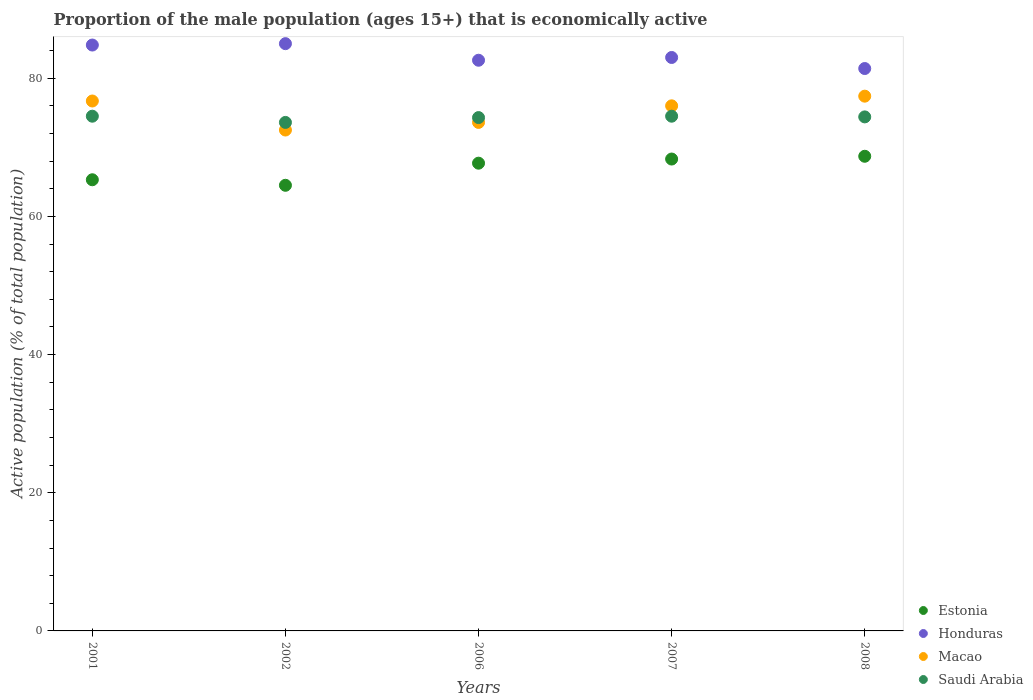Is the number of dotlines equal to the number of legend labels?
Your response must be concise. Yes. What is the proportion of the male population that is economically active in Honduras in 2002?
Give a very brief answer. 85. Across all years, what is the maximum proportion of the male population that is economically active in Macao?
Keep it short and to the point. 77.4. Across all years, what is the minimum proportion of the male population that is economically active in Macao?
Make the answer very short. 72.5. In which year was the proportion of the male population that is economically active in Honduras maximum?
Keep it short and to the point. 2002. In which year was the proportion of the male population that is economically active in Estonia minimum?
Provide a short and direct response. 2002. What is the total proportion of the male population that is economically active in Macao in the graph?
Your answer should be compact. 376.2. What is the difference between the proportion of the male population that is economically active in Honduras in 2002 and that in 2007?
Offer a very short reply. 2. What is the difference between the proportion of the male population that is economically active in Macao in 2002 and the proportion of the male population that is economically active in Estonia in 2008?
Offer a terse response. 3.8. What is the average proportion of the male population that is economically active in Honduras per year?
Offer a very short reply. 83.36. In the year 2002, what is the difference between the proportion of the male population that is economically active in Honduras and proportion of the male population that is economically active in Saudi Arabia?
Keep it short and to the point. 11.4. What is the ratio of the proportion of the male population that is economically active in Honduras in 2001 to that in 2006?
Your response must be concise. 1.03. Is the difference between the proportion of the male population that is economically active in Honduras in 2006 and 2008 greater than the difference between the proportion of the male population that is economically active in Saudi Arabia in 2006 and 2008?
Offer a very short reply. Yes. What is the difference between the highest and the second highest proportion of the male population that is economically active in Macao?
Give a very brief answer. 0.7. What is the difference between the highest and the lowest proportion of the male population that is economically active in Estonia?
Ensure brevity in your answer.  4.2. Is it the case that in every year, the sum of the proportion of the male population that is economically active in Macao and proportion of the male population that is economically active in Estonia  is greater than the sum of proportion of the male population that is economically active in Saudi Arabia and proportion of the male population that is economically active in Honduras?
Your answer should be compact. No. Is it the case that in every year, the sum of the proportion of the male population that is economically active in Macao and proportion of the male population that is economically active in Saudi Arabia  is greater than the proportion of the male population that is economically active in Honduras?
Keep it short and to the point. Yes. Does the proportion of the male population that is economically active in Honduras monotonically increase over the years?
Your answer should be compact. No. Is the proportion of the male population that is economically active in Honduras strictly greater than the proportion of the male population that is economically active in Macao over the years?
Give a very brief answer. Yes. Are the values on the major ticks of Y-axis written in scientific E-notation?
Make the answer very short. No. Does the graph contain any zero values?
Offer a terse response. No. Does the graph contain grids?
Offer a very short reply. No. How many legend labels are there?
Offer a terse response. 4. What is the title of the graph?
Offer a terse response. Proportion of the male population (ages 15+) that is economically active. Does "Liberia" appear as one of the legend labels in the graph?
Give a very brief answer. No. What is the label or title of the X-axis?
Provide a short and direct response. Years. What is the label or title of the Y-axis?
Provide a short and direct response. Active population (% of total population). What is the Active population (% of total population) of Estonia in 2001?
Give a very brief answer. 65.3. What is the Active population (% of total population) in Honduras in 2001?
Make the answer very short. 84.8. What is the Active population (% of total population) in Macao in 2001?
Provide a succinct answer. 76.7. What is the Active population (% of total population) in Saudi Arabia in 2001?
Give a very brief answer. 74.5. What is the Active population (% of total population) of Estonia in 2002?
Give a very brief answer. 64.5. What is the Active population (% of total population) in Honduras in 2002?
Offer a terse response. 85. What is the Active population (% of total population) in Macao in 2002?
Ensure brevity in your answer.  72.5. What is the Active population (% of total population) in Saudi Arabia in 2002?
Give a very brief answer. 73.6. What is the Active population (% of total population) in Estonia in 2006?
Ensure brevity in your answer.  67.7. What is the Active population (% of total population) of Honduras in 2006?
Keep it short and to the point. 82.6. What is the Active population (% of total population) in Macao in 2006?
Offer a very short reply. 73.6. What is the Active population (% of total population) in Saudi Arabia in 2006?
Offer a very short reply. 74.3. What is the Active population (% of total population) in Estonia in 2007?
Provide a short and direct response. 68.3. What is the Active population (% of total population) of Honduras in 2007?
Offer a terse response. 83. What is the Active population (% of total population) in Macao in 2007?
Offer a very short reply. 76. What is the Active population (% of total population) in Saudi Arabia in 2007?
Provide a short and direct response. 74.5. What is the Active population (% of total population) in Estonia in 2008?
Your answer should be compact. 68.7. What is the Active population (% of total population) of Honduras in 2008?
Provide a succinct answer. 81.4. What is the Active population (% of total population) in Macao in 2008?
Provide a short and direct response. 77.4. What is the Active population (% of total population) of Saudi Arabia in 2008?
Offer a very short reply. 74.4. Across all years, what is the maximum Active population (% of total population) of Estonia?
Your answer should be compact. 68.7. Across all years, what is the maximum Active population (% of total population) in Honduras?
Offer a terse response. 85. Across all years, what is the maximum Active population (% of total population) in Macao?
Provide a short and direct response. 77.4. Across all years, what is the maximum Active population (% of total population) in Saudi Arabia?
Provide a succinct answer. 74.5. Across all years, what is the minimum Active population (% of total population) of Estonia?
Make the answer very short. 64.5. Across all years, what is the minimum Active population (% of total population) in Honduras?
Offer a very short reply. 81.4. Across all years, what is the minimum Active population (% of total population) in Macao?
Your answer should be very brief. 72.5. Across all years, what is the minimum Active population (% of total population) of Saudi Arabia?
Your response must be concise. 73.6. What is the total Active population (% of total population) of Estonia in the graph?
Offer a very short reply. 334.5. What is the total Active population (% of total population) of Honduras in the graph?
Your response must be concise. 416.8. What is the total Active population (% of total population) in Macao in the graph?
Offer a very short reply. 376.2. What is the total Active population (% of total population) of Saudi Arabia in the graph?
Give a very brief answer. 371.3. What is the difference between the Active population (% of total population) in Honduras in 2001 and that in 2002?
Your response must be concise. -0.2. What is the difference between the Active population (% of total population) in Macao in 2001 and that in 2002?
Your answer should be compact. 4.2. What is the difference between the Active population (% of total population) in Honduras in 2001 and that in 2006?
Give a very brief answer. 2.2. What is the difference between the Active population (% of total population) of Macao in 2001 and that in 2006?
Offer a very short reply. 3.1. What is the difference between the Active population (% of total population) in Saudi Arabia in 2001 and that in 2006?
Provide a short and direct response. 0.2. What is the difference between the Active population (% of total population) of Honduras in 2001 and that in 2007?
Your response must be concise. 1.8. What is the difference between the Active population (% of total population) of Macao in 2001 and that in 2007?
Your response must be concise. 0.7. What is the difference between the Active population (% of total population) in Honduras in 2001 and that in 2008?
Your answer should be very brief. 3.4. What is the difference between the Active population (% of total population) in Macao in 2001 and that in 2008?
Offer a terse response. -0.7. What is the difference between the Active population (% of total population) of Saudi Arabia in 2001 and that in 2008?
Ensure brevity in your answer.  0.1. What is the difference between the Active population (% of total population) of Estonia in 2002 and that in 2006?
Offer a terse response. -3.2. What is the difference between the Active population (% of total population) in Honduras in 2002 and that in 2006?
Offer a terse response. 2.4. What is the difference between the Active population (% of total population) in Estonia in 2002 and that in 2007?
Your response must be concise. -3.8. What is the difference between the Active population (% of total population) in Macao in 2002 and that in 2007?
Give a very brief answer. -3.5. What is the difference between the Active population (% of total population) of Saudi Arabia in 2002 and that in 2007?
Ensure brevity in your answer.  -0.9. What is the difference between the Active population (% of total population) in Estonia in 2002 and that in 2008?
Provide a succinct answer. -4.2. What is the difference between the Active population (% of total population) in Honduras in 2002 and that in 2008?
Make the answer very short. 3.6. What is the difference between the Active population (% of total population) of Macao in 2002 and that in 2008?
Keep it short and to the point. -4.9. What is the difference between the Active population (% of total population) in Honduras in 2006 and that in 2007?
Your response must be concise. -0.4. What is the difference between the Active population (% of total population) of Estonia in 2006 and that in 2008?
Your answer should be very brief. -1. What is the difference between the Active population (% of total population) of Honduras in 2006 and that in 2008?
Keep it short and to the point. 1.2. What is the difference between the Active population (% of total population) of Macao in 2006 and that in 2008?
Keep it short and to the point. -3.8. What is the difference between the Active population (% of total population) of Saudi Arabia in 2006 and that in 2008?
Give a very brief answer. -0.1. What is the difference between the Active population (% of total population) in Macao in 2007 and that in 2008?
Make the answer very short. -1.4. What is the difference between the Active population (% of total population) of Saudi Arabia in 2007 and that in 2008?
Offer a terse response. 0.1. What is the difference between the Active population (% of total population) in Estonia in 2001 and the Active population (% of total population) in Honduras in 2002?
Make the answer very short. -19.7. What is the difference between the Active population (% of total population) of Estonia in 2001 and the Active population (% of total population) of Macao in 2002?
Make the answer very short. -7.2. What is the difference between the Active population (% of total population) in Honduras in 2001 and the Active population (% of total population) in Saudi Arabia in 2002?
Your response must be concise. 11.2. What is the difference between the Active population (% of total population) of Estonia in 2001 and the Active population (% of total population) of Honduras in 2006?
Keep it short and to the point. -17.3. What is the difference between the Active population (% of total population) in Estonia in 2001 and the Active population (% of total population) in Macao in 2006?
Your answer should be very brief. -8.3. What is the difference between the Active population (% of total population) in Estonia in 2001 and the Active population (% of total population) in Saudi Arabia in 2006?
Ensure brevity in your answer.  -9. What is the difference between the Active population (% of total population) in Honduras in 2001 and the Active population (% of total population) in Saudi Arabia in 2006?
Provide a succinct answer. 10.5. What is the difference between the Active population (% of total population) of Macao in 2001 and the Active population (% of total population) of Saudi Arabia in 2006?
Offer a very short reply. 2.4. What is the difference between the Active population (% of total population) of Estonia in 2001 and the Active population (% of total population) of Honduras in 2007?
Your answer should be compact. -17.7. What is the difference between the Active population (% of total population) in Estonia in 2001 and the Active population (% of total population) in Macao in 2007?
Give a very brief answer. -10.7. What is the difference between the Active population (% of total population) in Estonia in 2001 and the Active population (% of total population) in Saudi Arabia in 2007?
Offer a terse response. -9.2. What is the difference between the Active population (% of total population) in Estonia in 2001 and the Active population (% of total population) in Honduras in 2008?
Your response must be concise. -16.1. What is the difference between the Active population (% of total population) in Estonia in 2001 and the Active population (% of total population) in Macao in 2008?
Provide a short and direct response. -12.1. What is the difference between the Active population (% of total population) in Honduras in 2001 and the Active population (% of total population) in Macao in 2008?
Provide a succinct answer. 7.4. What is the difference between the Active population (% of total population) in Macao in 2001 and the Active population (% of total population) in Saudi Arabia in 2008?
Your answer should be compact. 2.3. What is the difference between the Active population (% of total population) in Estonia in 2002 and the Active population (% of total population) in Honduras in 2006?
Your answer should be compact. -18.1. What is the difference between the Active population (% of total population) in Honduras in 2002 and the Active population (% of total population) in Macao in 2006?
Give a very brief answer. 11.4. What is the difference between the Active population (% of total population) of Macao in 2002 and the Active population (% of total population) of Saudi Arabia in 2006?
Offer a very short reply. -1.8. What is the difference between the Active population (% of total population) of Estonia in 2002 and the Active population (% of total population) of Honduras in 2007?
Ensure brevity in your answer.  -18.5. What is the difference between the Active population (% of total population) in Honduras in 2002 and the Active population (% of total population) in Macao in 2007?
Provide a short and direct response. 9. What is the difference between the Active population (% of total population) of Macao in 2002 and the Active population (% of total population) of Saudi Arabia in 2007?
Your response must be concise. -2. What is the difference between the Active population (% of total population) of Estonia in 2002 and the Active population (% of total population) of Honduras in 2008?
Your answer should be compact. -16.9. What is the difference between the Active population (% of total population) of Estonia in 2002 and the Active population (% of total population) of Saudi Arabia in 2008?
Make the answer very short. -9.9. What is the difference between the Active population (% of total population) of Honduras in 2002 and the Active population (% of total population) of Macao in 2008?
Your response must be concise. 7.6. What is the difference between the Active population (% of total population) in Honduras in 2002 and the Active population (% of total population) in Saudi Arabia in 2008?
Ensure brevity in your answer.  10.6. What is the difference between the Active population (% of total population) in Macao in 2002 and the Active population (% of total population) in Saudi Arabia in 2008?
Your answer should be compact. -1.9. What is the difference between the Active population (% of total population) of Estonia in 2006 and the Active population (% of total population) of Honduras in 2007?
Provide a succinct answer. -15.3. What is the difference between the Active population (% of total population) in Estonia in 2006 and the Active population (% of total population) in Saudi Arabia in 2007?
Provide a succinct answer. -6.8. What is the difference between the Active population (% of total population) of Macao in 2006 and the Active population (% of total population) of Saudi Arabia in 2007?
Give a very brief answer. -0.9. What is the difference between the Active population (% of total population) in Estonia in 2006 and the Active population (% of total population) in Honduras in 2008?
Offer a very short reply. -13.7. What is the difference between the Active population (% of total population) in Estonia in 2006 and the Active population (% of total population) in Saudi Arabia in 2008?
Offer a terse response. -6.7. What is the difference between the Active population (% of total population) of Honduras in 2006 and the Active population (% of total population) of Macao in 2008?
Make the answer very short. 5.2. What is the difference between the Active population (% of total population) of Macao in 2006 and the Active population (% of total population) of Saudi Arabia in 2008?
Provide a short and direct response. -0.8. What is the difference between the Active population (% of total population) in Honduras in 2007 and the Active population (% of total population) in Macao in 2008?
Your response must be concise. 5.6. What is the average Active population (% of total population) of Estonia per year?
Offer a very short reply. 66.9. What is the average Active population (% of total population) of Honduras per year?
Your answer should be very brief. 83.36. What is the average Active population (% of total population) in Macao per year?
Provide a succinct answer. 75.24. What is the average Active population (% of total population) in Saudi Arabia per year?
Make the answer very short. 74.26. In the year 2001, what is the difference between the Active population (% of total population) of Estonia and Active population (% of total population) of Honduras?
Your answer should be very brief. -19.5. In the year 2001, what is the difference between the Active population (% of total population) of Macao and Active population (% of total population) of Saudi Arabia?
Give a very brief answer. 2.2. In the year 2002, what is the difference between the Active population (% of total population) in Estonia and Active population (% of total population) in Honduras?
Ensure brevity in your answer.  -20.5. In the year 2002, what is the difference between the Active population (% of total population) in Estonia and Active population (% of total population) in Macao?
Ensure brevity in your answer.  -8. In the year 2002, what is the difference between the Active population (% of total population) in Macao and Active population (% of total population) in Saudi Arabia?
Provide a succinct answer. -1.1. In the year 2006, what is the difference between the Active population (% of total population) in Estonia and Active population (% of total population) in Honduras?
Give a very brief answer. -14.9. In the year 2006, what is the difference between the Active population (% of total population) in Estonia and Active population (% of total population) in Saudi Arabia?
Give a very brief answer. -6.6. In the year 2006, what is the difference between the Active population (% of total population) in Macao and Active population (% of total population) in Saudi Arabia?
Offer a very short reply. -0.7. In the year 2007, what is the difference between the Active population (% of total population) in Estonia and Active population (% of total population) in Honduras?
Your answer should be very brief. -14.7. In the year 2007, what is the difference between the Active population (% of total population) of Estonia and Active population (% of total population) of Macao?
Your answer should be compact. -7.7. In the year 2007, what is the difference between the Active population (% of total population) of Estonia and Active population (% of total population) of Saudi Arabia?
Make the answer very short. -6.2. In the year 2007, what is the difference between the Active population (% of total population) in Honduras and Active population (% of total population) in Macao?
Offer a very short reply. 7. In the year 2007, what is the difference between the Active population (% of total population) in Macao and Active population (% of total population) in Saudi Arabia?
Provide a succinct answer. 1.5. In the year 2008, what is the difference between the Active population (% of total population) of Estonia and Active population (% of total population) of Honduras?
Give a very brief answer. -12.7. In the year 2008, what is the difference between the Active population (% of total population) in Estonia and Active population (% of total population) in Saudi Arabia?
Your answer should be compact. -5.7. In the year 2008, what is the difference between the Active population (% of total population) of Honduras and Active population (% of total population) of Macao?
Your answer should be very brief. 4. What is the ratio of the Active population (% of total population) of Estonia in 2001 to that in 2002?
Give a very brief answer. 1.01. What is the ratio of the Active population (% of total population) in Honduras in 2001 to that in 2002?
Keep it short and to the point. 1. What is the ratio of the Active population (% of total population) of Macao in 2001 to that in 2002?
Your response must be concise. 1.06. What is the ratio of the Active population (% of total population) in Saudi Arabia in 2001 to that in 2002?
Provide a succinct answer. 1.01. What is the ratio of the Active population (% of total population) of Estonia in 2001 to that in 2006?
Provide a short and direct response. 0.96. What is the ratio of the Active population (% of total population) in Honduras in 2001 to that in 2006?
Provide a short and direct response. 1.03. What is the ratio of the Active population (% of total population) in Macao in 2001 to that in 2006?
Make the answer very short. 1.04. What is the ratio of the Active population (% of total population) of Estonia in 2001 to that in 2007?
Make the answer very short. 0.96. What is the ratio of the Active population (% of total population) of Honduras in 2001 to that in 2007?
Offer a terse response. 1.02. What is the ratio of the Active population (% of total population) in Macao in 2001 to that in 2007?
Provide a short and direct response. 1.01. What is the ratio of the Active population (% of total population) in Saudi Arabia in 2001 to that in 2007?
Provide a short and direct response. 1. What is the ratio of the Active population (% of total population) in Estonia in 2001 to that in 2008?
Your answer should be very brief. 0.95. What is the ratio of the Active population (% of total population) in Honduras in 2001 to that in 2008?
Provide a short and direct response. 1.04. What is the ratio of the Active population (% of total population) of Macao in 2001 to that in 2008?
Ensure brevity in your answer.  0.99. What is the ratio of the Active population (% of total population) in Saudi Arabia in 2001 to that in 2008?
Keep it short and to the point. 1. What is the ratio of the Active population (% of total population) of Estonia in 2002 to that in 2006?
Offer a very short reply. 0.95. What is the ratio of the Active population (% of total population) in Honduras in 2002 to that in 2006?
Give a very brief answer. 1.03. What is the ratio of the Active population (% of total population) in Macao in 2002 to that in 2006?
Your answer should be very brief. 0.99. What is the ratio of the Active population (% of total population) of Saudi Arabia in 2002 to that in 2006?
Your answer should be very brief. 0.99. What is the ratio of the Active population (% of total population) of Honduras in 2002 to that in 2007?
Provide a short and direct response. 1.02. What is the ratio of the Active population (% of total population) of Macao in 2002 to that in 2007?
Offer a very short reply. 0.95. What is the ratio of the Active population (% of total population) in Saudi Arabia in 2002 to that in 2007?
Your response must be concise. 0.99. What is the ratio of the Active population (% of total population) of Estonia in 2002 to that in 2008?
Your answer should be very brief. 0.94. What is the ratio of the Active population (% of total population) in Honduras in 2002 to that in 2008?
Ensure brevity in your answer.  1.04. What is the ratio of the Active population (% of total population) in Macao in 2002 to that in 2008?
Make the answer very short. 0.94. What is the ratio of the Active population (% of total population) in Estonia in 2006 to that in 2007?
Your response must be concise. 0.99. What is the ratio of the Active population (% of total population) in Honduras in 2006 to that in 2007?
Provide a succinct answer. 1. What is the ratio of the Active population (% of total population) in Macao in 2006 to that in 2007?
Keep it short and to the point. 0.97. What is the ratio of the Active population (% of total population) in Saudi Arabia in 2006 to that in 2007?
Give a very brief answer. 1. What is the ratio of the Active population (% of total population) in Estonia in 2006 to that in 2008?
Offer a very short reply. 0.99. What is the ratio of the Active population (% of total population) in Honduras in 2006 to that in 2008?
Offer a terse response. 1.01. What is the ratio of the Active population (% of total population) in Macao in 2006 to that in 2008?
Your response must be concise. 0.95. What is the ratio of the Active population (% of total population) in Estonia in 2007 to that in 2008?
Your response must be concise. 0.99. What is the ratio of the Active population (% of total population) of Honduras in 2007 to that in 2008?
Provide a short and direct response. 1.02. What is the ratio of the Active population (% of total population) in Macao in 2007 to that in 2008?
Keep it short and to the point. 0.98. What is the ratio of the Active population (% of total population) in Saudi Arabia in 2007 to that in 2008?
Offer a very short reply. 1. What is the difference between the highest and the second highest Active population (% of total population) of Estonia?
Provide a succinct answer. 0.4. What is the difference between the highest and the second highest Active population (% of total population) in Macao?
Your answer should be compact. 0.7. What is the difference between the highest and the lowest Active population (% of total population) in Estonia?
Your answer should be compact. 4.2. What is the difference between the highest and the lowest Active population (% of total population) in Macao?
Make the answer very short. 4.9. What is the difference between the highest and the lowest Active population (% of total population) in Saudi Arabia?
Offer a terse response. 0.9. 